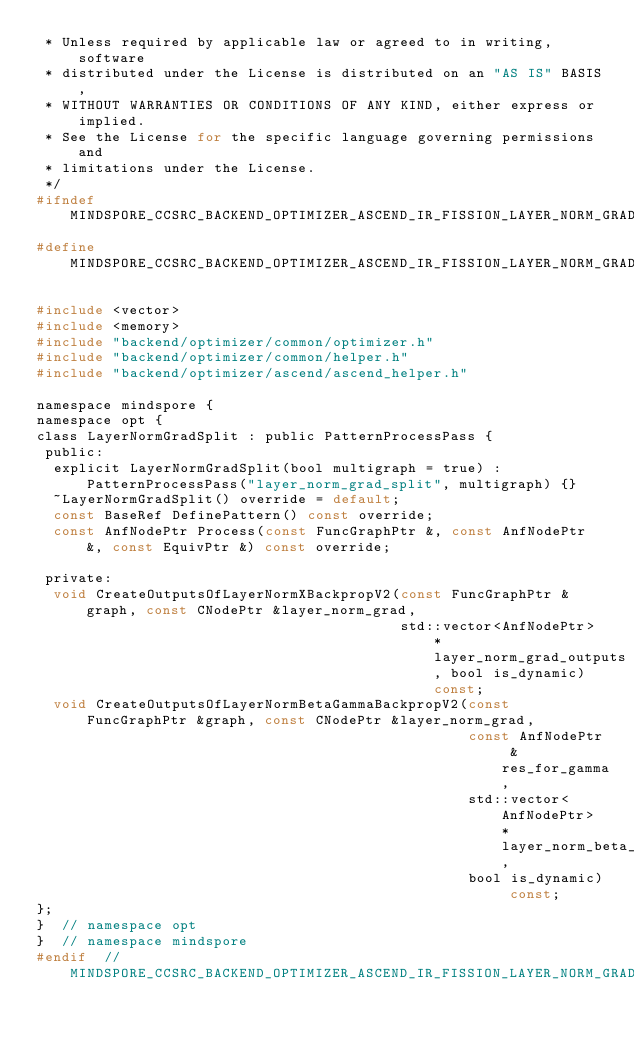Convert code to text. <code><loc_0><loc_0><loc_500><loc_500><_C_> * Unless required by applicable law or agreed to in writing, software
 * distributed under the License is distributed on an "AS IS" BASIS,
 * WITHOUT WARRANTIES OR CONDITIONS OF ANY KIND, either express or implied.
 * See the License for the specific language governing permissions and
 * limitations under the License.
 */
#ifndef MINDSPORE_CCSRC_BACKEND_OPTIMIZER_ASCEND_IR_FISSION_LAYER_NORM_GRAD_SPLIT_H_
#define MINDSPORE_CCSRC_BACKEND_OPTIMIZER_ASCEND_IR_FISSION_LAYER_NORM_GRAD_SPLIT_H_

#include <vector>
#include <memory>
#include "backend/optimizer/common/optimizer.h"
#include "backend/optimizer/common/helper.h"
#include "backend/optimizer/ascend/ascend_helper.h"

namespace mindspore {
namespace opt {
class LayerNormGradSplit : public PatternProcessPass {
 public:
  explicit LayerNormGradSplit(bool multigraph = true) : PatternProcessPass("layer_norm_grad_split", multigraph) {}
  ~LayerNormGradSplit() override = default;
  const BaseRef DefinePattern() const override;
  const AnfNodePtr Process(const FuncGraphPtr &, const AnfNodePtr &, const EquivPtr &) const override;

 private:
  void CreateOutputsOfLayerNormXBackpropV2(const FuncGraphPtr &graph, const CNodePtr &layer_norm_grad,
                                           std::vector<AnfNodePtr> *layer_norm_grad_outputs, bool is_dynamic) const;
  void CreateOutputsOfLayerNormBetaGammaBackpropV2(const FuncGraphPtr &graph, const CNodePtr &layer_norm_grad,
                                                   const AnfNodePtr &res_for_gamma,
                                                   std::vector<AnfNodePtr> *layer_norm_beta_gamma_outputs,
                                                   bool is_dynamic) const;
};
}  // namespace opt
}  // namespace mindspore
#endif  // MINDSPORE_CCSRC_BACKEND_OPTIMIZER_ASCEND_IR_FISSION_LAYER_NORM_GRAD_SPLIT_H_
</code> 